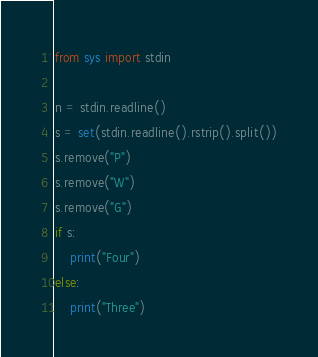<code> <loc_0><loc_0><loc_500><loc_500><_Python_>from sys import stdin

n = stdin.readline()
s = set(stdin.readline().rstrip().split())
s.remove("P")
s.remove("W")
s.remove("G")
if s:
    print("Four")
else:
    print("Three")

</code> 